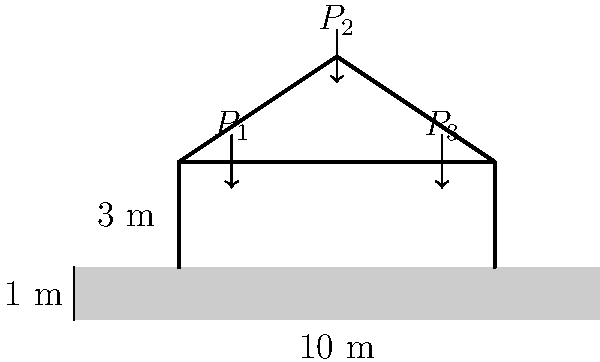As the guitarist preparing for a major concert, you're reviewing the structural integrity of the stage design. The truss system supporting the lighting and sound equipment forms a triangle with a 10 m base and 3 m height. Three point loads are applied: $P_1 = 15$ kN and $P_3 = 15$ kN at the lower joints, and $P_2 = 25$ kN at the apex. Assuming the truss behaves as a simply supported beam, what is the maximum bending moment (in kN·m) in the truss system? To find the maximum bending moment, we'll follow these steps:

1) First, calculate the reaction forces at the supports:
   Sum of moments about left support = 0
   $R_B \cdot 10 - 15 \cdot 2 - 25 \cdot 5 - 15 \cdot 8 = 0$
   $R_B = \frac{15 \cdot 2 + 25 \cdot 5 + 15 \cdot 8}{10} = 27.5$ kN

   Sum of vertical forces = 0
   $R_A + R_B - 15 - 25 - 15 = 0$
   $R_A = 55 - 27.5 = 27.5$ kN

2) Now, we can calculate the shear force and bending moment at each load point:
   At $x = 0$ m: $V = 27.5$ kN, $M = 0$ kN·m
   At $x = 2$ m: $V = 12.5$ kN, $M = 27.5 \cdot 2 - 15 \cdot 0 = 55$ kN·m
   At $x = 5$ m: $V = -12.5$ kN, $M = 27.5 \cdot 5 - 15 \cdot 3 - 25 \cdot 0 = 92.5$ kN·m
   At $x = 8$ m: $V = -27.5$ kN, $M = 27.5 \cdot 8 - 15 \cdot 6 - 25 \cdot 3 = 55$ kN·m
   At $x = 10$ m: $V = 0$ kN, $M = 0$ kN·m

3) The maximum bending moment occurs at $x = 5$ m (the apex of the truss) and is 92.5 kN·m.
Answer: 92.5 kN·m 